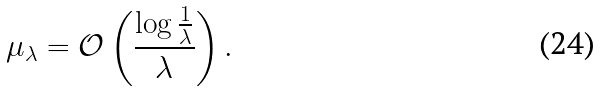Convert formula to latex. <formula><loc_0><loc_0><loc_500><loc_500>\mu _ { \lambda } = \mathcal { O } \left ( \frac { \log \frac { 1 } { \lambda } } { \lambda } \right ) .</formula> 